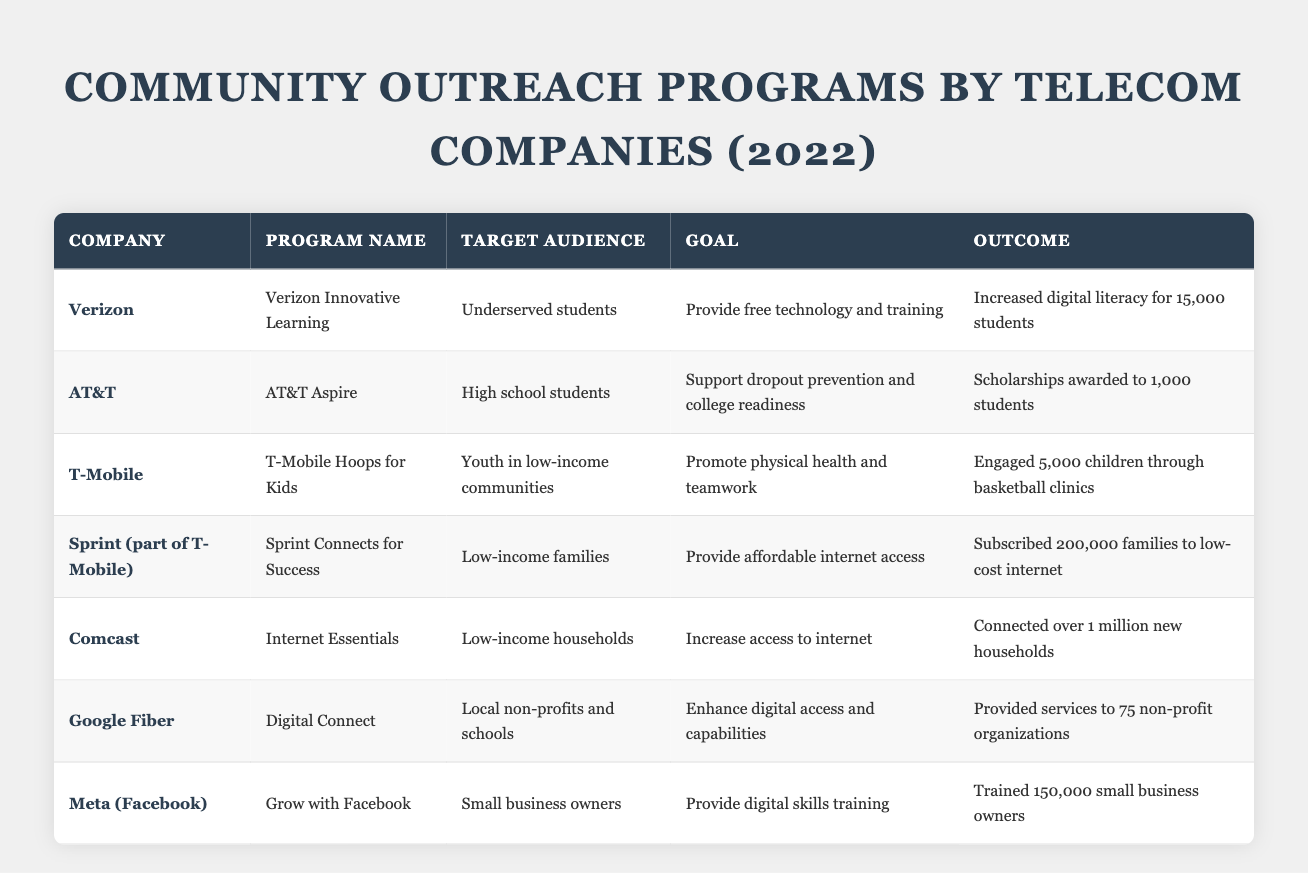What community outreach program aims to provide free technology and training? The table lists several programs, and by examining the "Goal" column, we find that "Verizon Innovative Learning" explicitly states its goal is to "Provide free technology and training."
Answer: Verizon Innovative Learning Which company engaged 5,000 children through basketball clinics? Looking at the "Outcome" column, we see that "T-Mobile Hoops for Kids" mentions engaging "5,000 children through basketball clinics."
Answer: T-Mobile How many scholarships did AT&T award in its program? From the "Outcome" column for AT&T's "Aspire" program, it indicates that "Scholarships awarded to 1,000 students."
Answer: 1,000 What was the primary target audience for Comcast's Internet Essentials program? By checking the "Target Audience" column for Comcast, it shows that the primary audience is "Low-income households."
Answer: Low-income households Which program provided services to the highest number of beneficiaries? We compare the numbers from the "Outcome" column: Comcast connected over 1 million new households, which is greater than any other outcome listed.
Answer: Internet Essentials Which company had a program focused specifically on digital skills training for small business owners? The program "Grow with Facebook" under "Meta (Facebook)" is focused on digital skills training for "Small business owners."
Answer: Meta (Facebook) What was the goal of Sprint Connects for Success? Referencing the "Goal" column for Sprint Connects for Success, it states its goal is to "Provide affordable internet access."
Answer: Provide affordable internet access Which company provided services to local non-profits and schools? Looking at the "Target Audience" for Google Fiber's "Digital Connect," it specifies that the services were provided to "Local non-profits and schools."
Answer: Google Fiber Calculate the total number of students helped from the Verizon and AT&T programs combined. From the table, Verizon helped 15,000 students and AT&T awarded scholarships to 1,000 students. Combining gives 15,000 + 1,000 = 16,000.
Answer: 16,000 Did any company focus its program on youth in low-income communities? Yes, the "T-Mobile Hoops for Kids" program explicitly targets "Youth in low-income communities."
Answer: Yes Which program had the least number of people engaged in its outcome? Comparing the numbers in the "Outcome" column, "Digital Connect" by Google Fiber provided services to 75 non-profit organizations, which is lower than the others.
Answer: Digital Connect Identify the program that aimed to increase digital literacy. The program aimed at increasing digital literacy is "Verizon Innovative Learning," as stated in its goal to "Provide free technology and training."
Answer: Verizon Innovative Learning 